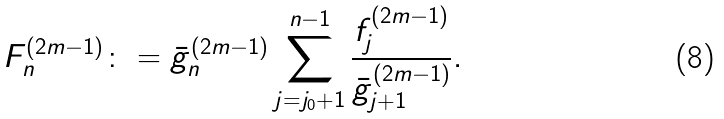Convert formula to latex. <formula><loc_0><loc_0><loc_500><loc_500>F ^ { ( 2 m - 1 ) } _ { n } \colon = \bar { g } _ { n } ^ { ( 2 m - 1 ) } \sum _ { j = j _ { 0 } + 1 } ^ { n - 1 } \frac { f _ { j } ^ { ( 2 m - 1 ) } } { \bar { g } _ { j + 1 } ^ { ( 2 m - 1 ) } } .</formula> 